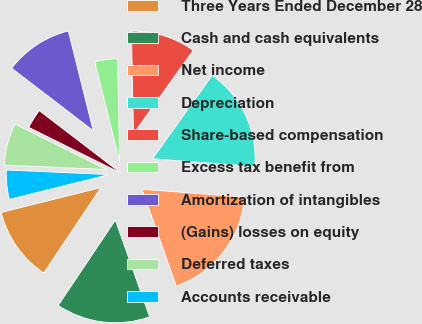<chart> <loc_0><loc_0><loc_500><loc_500><pie_chart><fcel>Three Years Ended December 28<fcel>Cash and cash equivalents<fcel>Net income<fcel>Depreciation<fcel>Share-based compensation<fcel>Excess tax benefit from<fcel>Amortization of intangibles<fcel>(Gains) losses on equity<fcel>Deferred taxes<fcel>Accounts receivable<nl><fcel>11.73%<fcel>14.8%<fcel>18.37%<fcel>16.33%<fcel>10.2%<fcel>3.57%<fcel>10.71%<fcel>3.06%<fcel>6.63%<fcel>4.59%<nl></chart> 